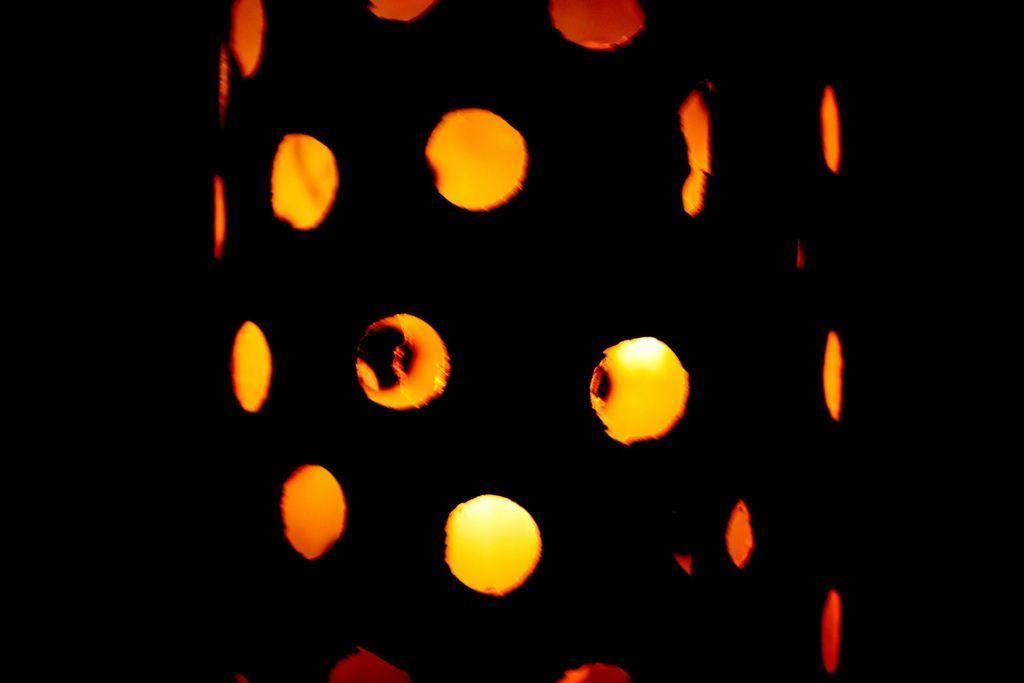In one or two sentences, can you explain what this image depicts? In this image I can see a cylindrical object in the center of the image with some holes. I can see some light through these circular holes and the background is black. 